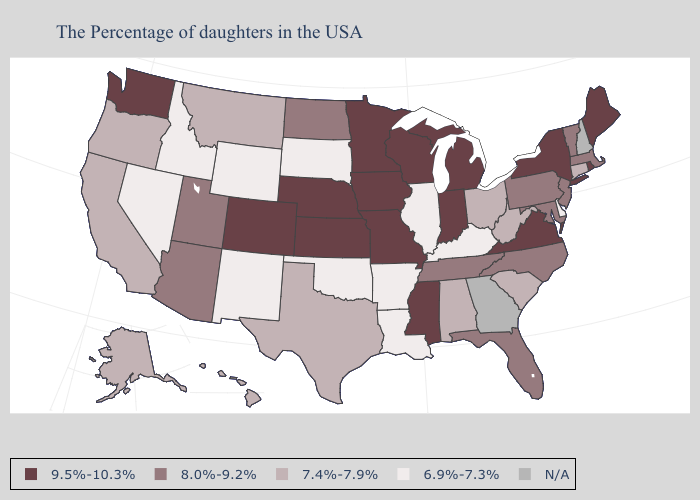Among the states that border Oklahoma , does New Mexico have the lowest value?
Answer briefly. Yes. Among the states that border Alabama , which have the highest value?
Be succinct. Mississippi. What is the highest value in the West ?
Give a very brief answer. 9.5%-10.3%. Name the states that have a value in the range 9.5%-10.3%?
Quick response, please. Maine, Rhode Island, New York, Virginia, Michigan, Indiana, Wisconsin, Mississippi, Missouri, Minnesota, Iowa, Kansas, Nebraska, Colorado, Washington. Name the states that have a value in the range 6.9%-7.3%?
Keep it brief. Delaware, Kentucky, Illinois, Louisiana, Arkansas, Oklahoma, South Dakota, Wyoming, New Mexico, Idaho, Nevada. What is the highest value in the Northeast ?
Write a very short answer. 9.5%-10.3%. Does Mississippi have the highest value in the USA?
Give a very brief answer. Yes. Does Connecticut have the lowest value in the Northeast?
Answer briefly. Yes. Does Nebraska have the highest value in the MidWest?
Answer briefly. Yes. Does the first symbol in the legend represent the smallest category?
Quick response, please. No. Among the states that border Connecticut , which have the highest value?
Short answer required. Rhode Island, New York. Among the states that border South Dakota , does Nebraska have the lowest value?
Answer briefly. No. Name the states that have a value in the range 9.5%-10.3%?
Write a very short answer. Maine, Rhode Island, New York, Virginia, Michigan, Indiana, Wisconsin, Mississippi, Missouri, Minnesota, Iowa, Kansas, Nebraska, Colorado, Washington. 